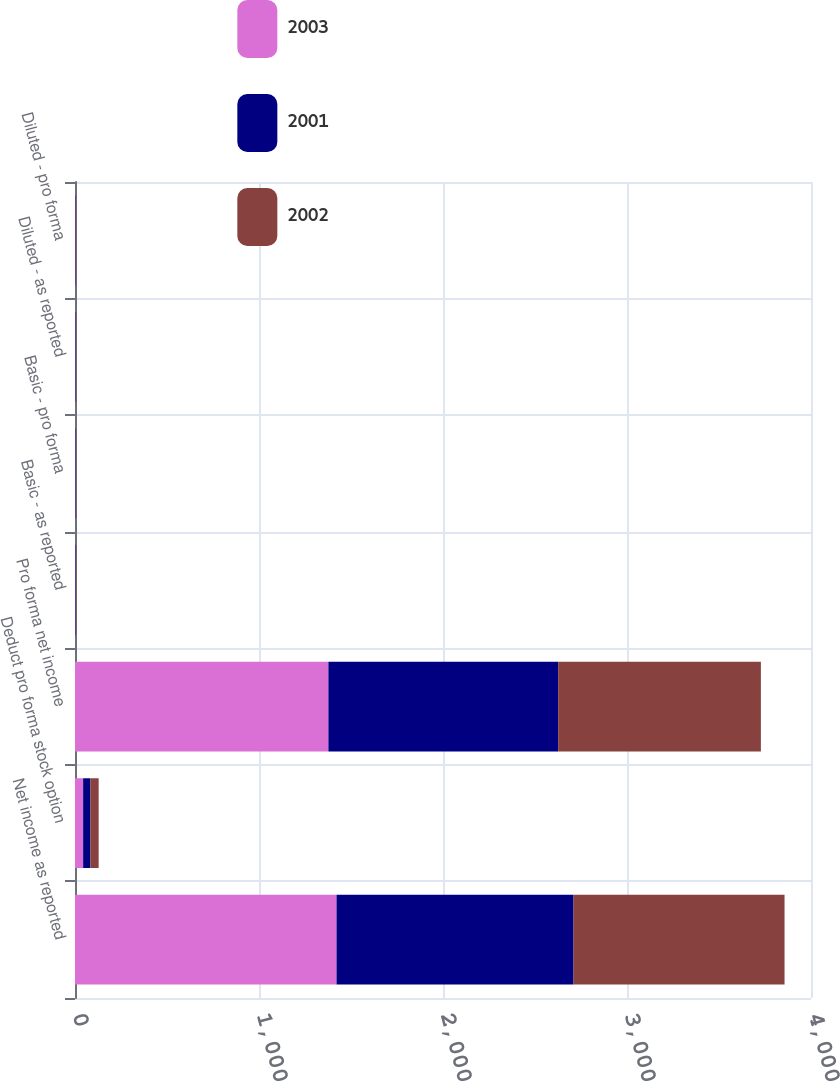<chart> <loc_0><loc_0><loc_500><loc_500><stacked_bar_chart><ecel><fcel>Net income as reported<fcel>Deduct pro forma stock option<fcel>Pro forma net income<fcel>Basic - as reported<fcel>Basic - pro forma<fcel>Diluted - as reported<fcel>Diluted - pro forma<nl><fcel>2003<fcel>1421.3<fcel>44.2<fcel>1377.1<fcel>2.6<fcel>2.52<fcel>2.46<fcel>2.38<nl><fcel>2001<fcel>1288.3<fcel>39.5<fcel>1248.8<fcel>2.33<fcel>2.26<fcel>2.19<fcel>2.12<nl><fcel>2002<fcel>1146.6<fcel>44.9<fcel>1101.7<fcel>2.02<fcel>1.94<fcel>1.89<fcel>1.81<nl></chart> 